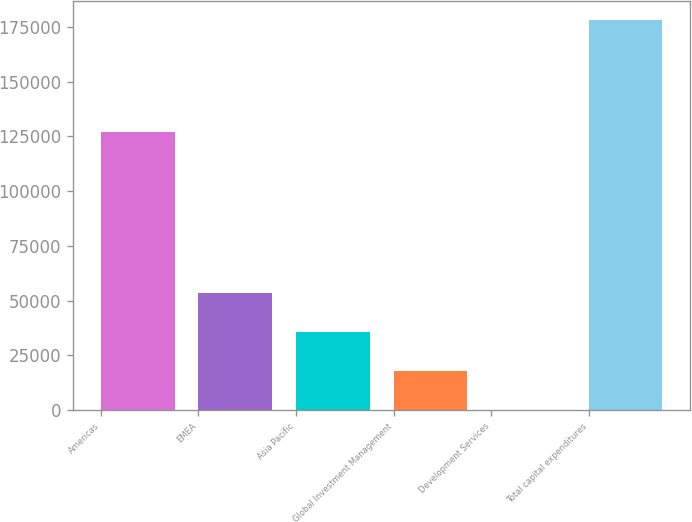<chart> <loc_0><loc_0><loc_500><loc_500><bar_chart><fcel>Americas<fcel>EMEA<fcel>Asia Pacific<fcel>Global Investment Management<fcel>Development Services<fcel>Total capital expenditures<nl><fcel>127135<fcel>53451.1<fcel>35652.4<fcel>17853.7<fcel>55<fcel>178042<nl></chart> 